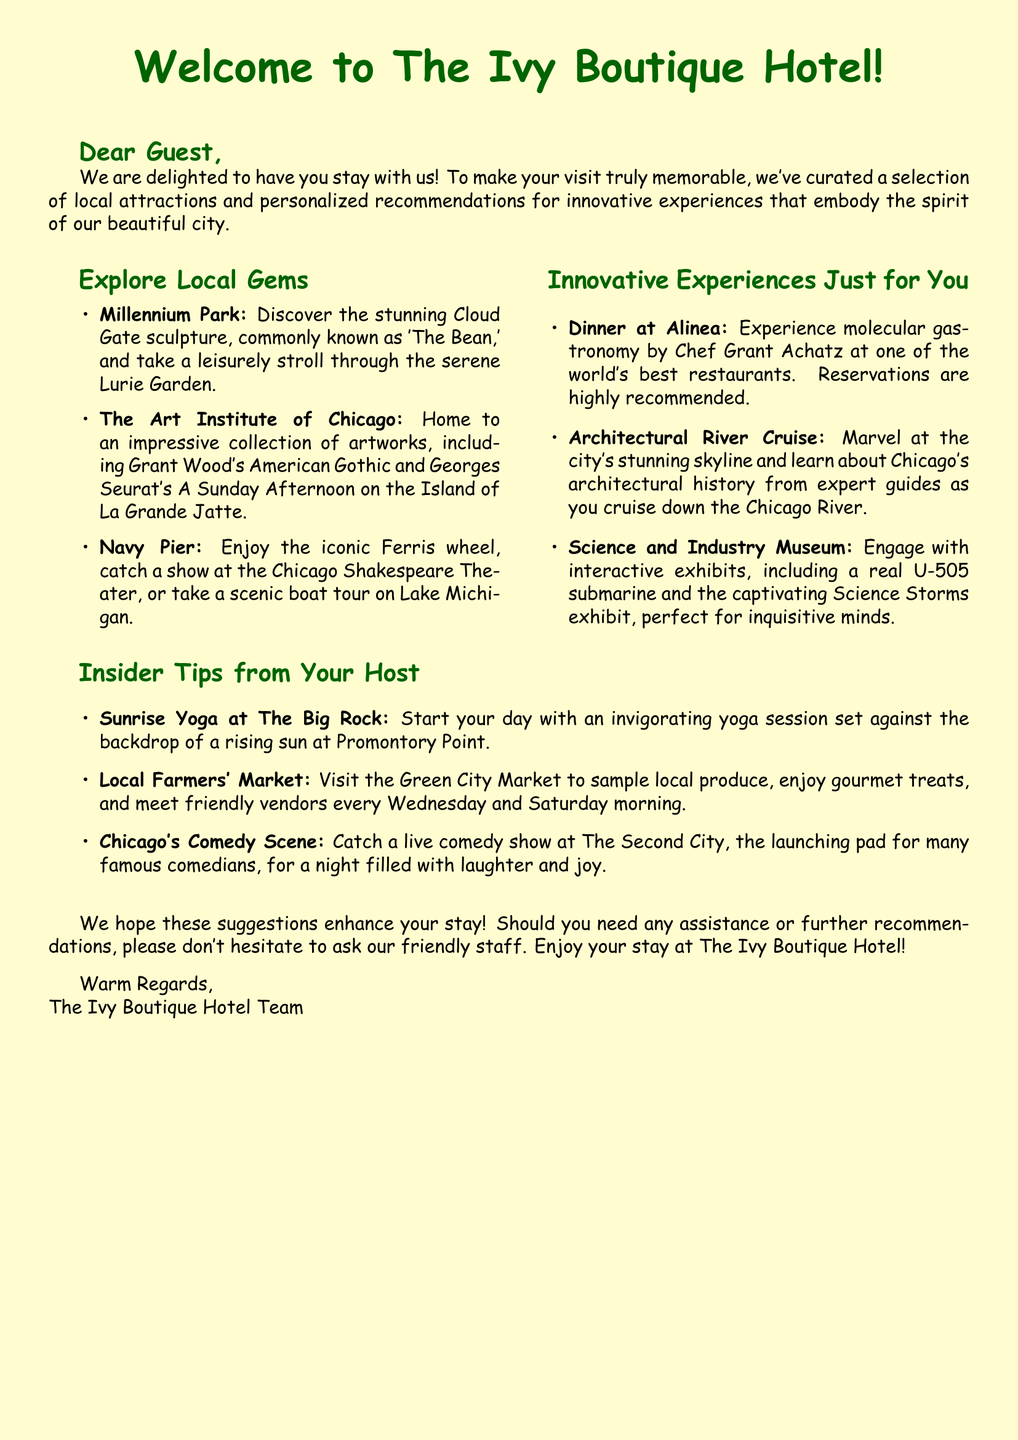What is the name of the hotel? The document prominently mentions the name of the hotel in the greeting.
Answer: The Ivy Boutique Hotel What is an attraction mentioned for local gems? The document includes a list of attractions, one of which is highlighted as a local gem.
Answer: Millennium Park Who is the chef at Alinea? The card specifies the chef of Alinea in the section on innovative experiences.
Answer: Grant Achatz What type of yoga is suggested at The Big Rock? The document provides a specific activity that guests are encouraged to participate in during their stay.
Answer: Sunrise Yoga How often does the Farmers' Market occur? The document suggests when visitors can attend the local Farmers' Market.
Answer: Wednesday and Saturday What type of cuisine is Alinea known for? Alinea is specifically mentioned for its culinary style in the recommendations section.
Answer: Molecular gastronomy What type of entertainment can be found at The Second City? The document mentions this venue in the insider tips related to local entertainment.
Answer: Comedy show How many local attractions are listed in the document? There are several local attractions mentioned in the document that visitors can explore.
Answer: 3 